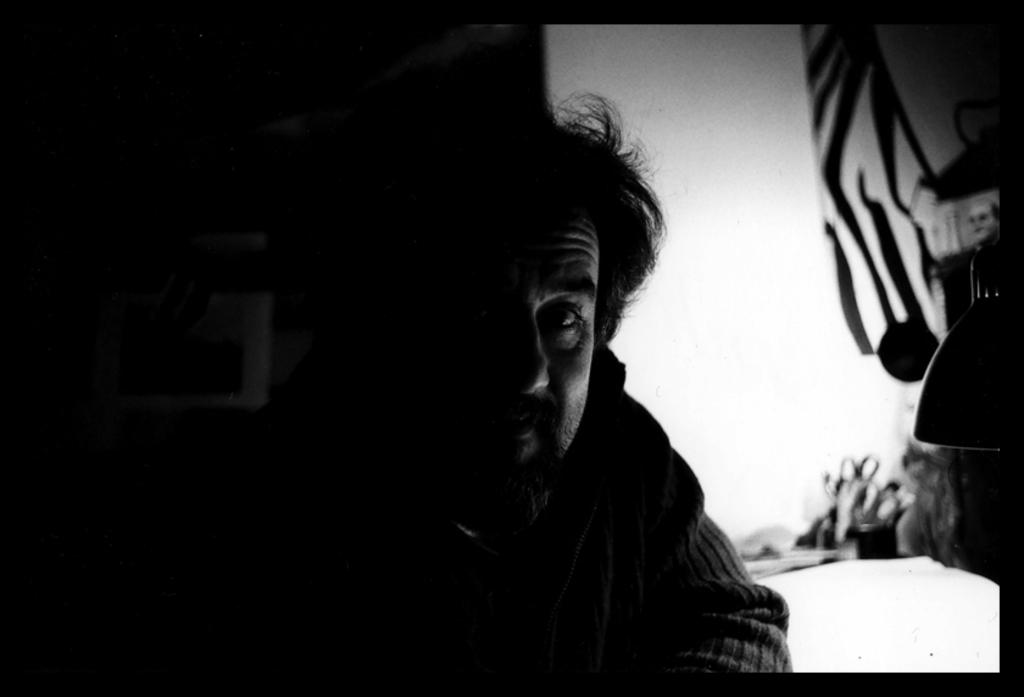What is the overall tone or appearance of the image? The picture is dark. Can you identify any subjects or figures in the image? Yes, there is a person in the image. How would you describe the background of the image? The background of the image is blurry. What type of canvas is being used by the person in the image? There is no canvas present in the image, as it features a person in a dark and blurry setting. 